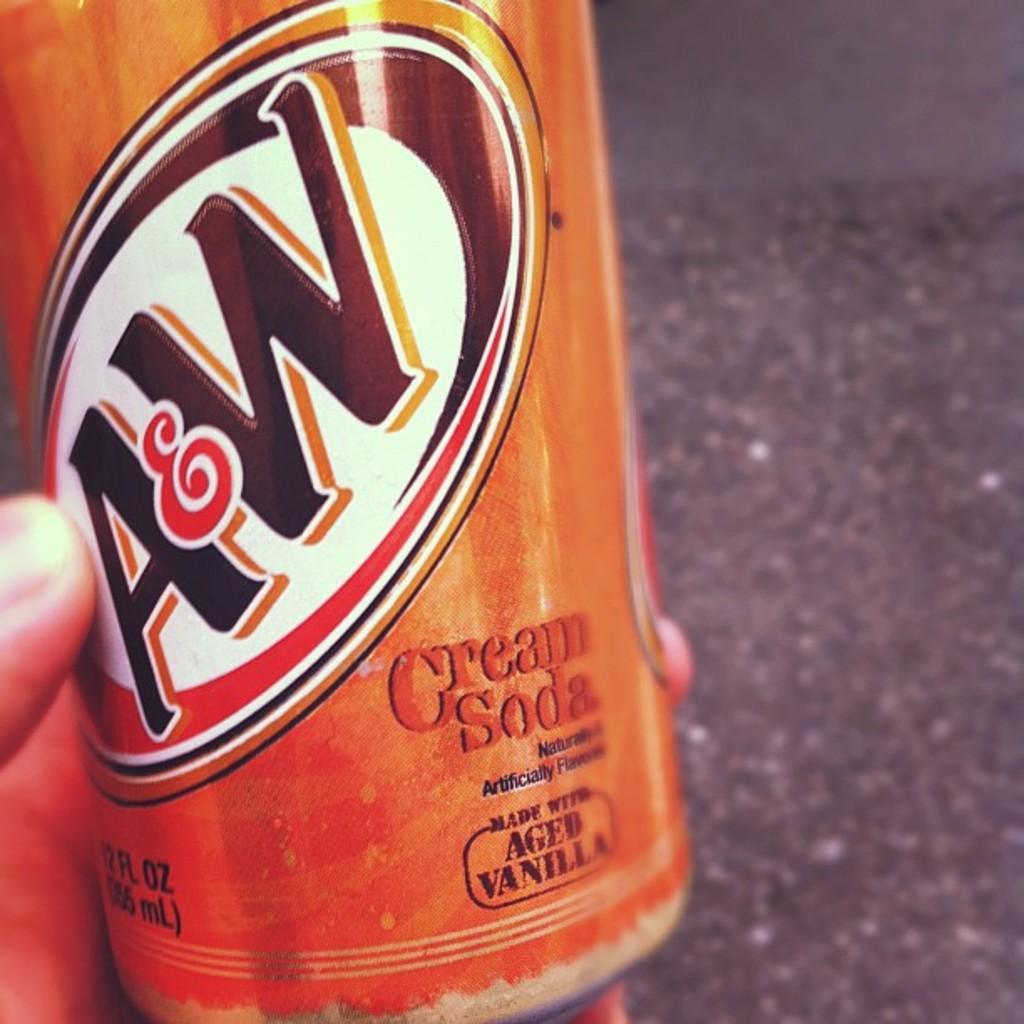In one or two sentences, can you explain what this image depicts? In this image we can see hand of a person holding a bottle which is truncated. On the right side of the image we can see grey color. 